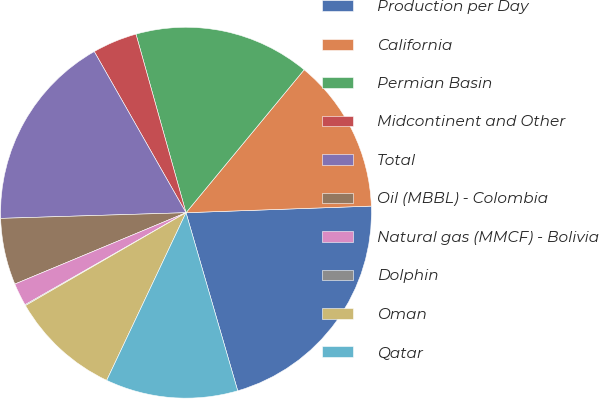Convert chart to OTSL. <chart><loc_0><loc_0><loc_500><loc_500><pie_chart><fcel>Production per Day<fcel>California<fcel>Permian Basin<fcel>Midcontinent and Other<fcel>Total<fcel>Oil (MBBL) - Colombia<fcel>Natural gas (MMCF) - Bolivia<fcel>Dolphin<fcel>Oman<fcel>Qatar<nl><fcel>21.07%<fcel>13.44%<fcel>15.34%<fcel>3.89%<fcel>17.25%<fcel>5.8%<fcel>1.98%<fcel>0.08%<fcel>9.62%<fcel>11.53%<nl></chart> 